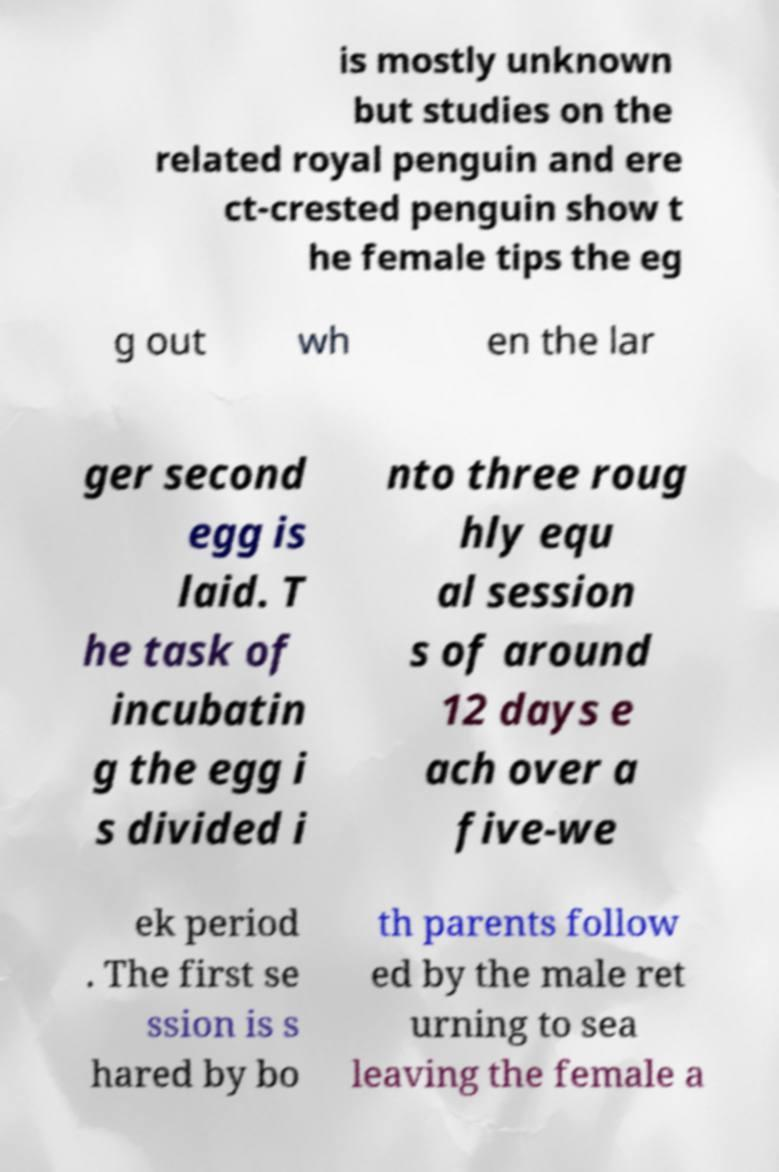For documentation purposes, I need the text within this image transcribed. Could you provide that? is mostly unknown but studies on the related royal penguin and ere ct-crested penguin show t he female tips the eg g out wh en the lar ger second egg is laid. T he task of incubatin g the egg i s divided i nto three roug hly equ al session s of around 12 days e ach over a five-we ek period . The first se ssion is s hared by bo th parents follow ed by the male ret urning to sea leaving the female a 